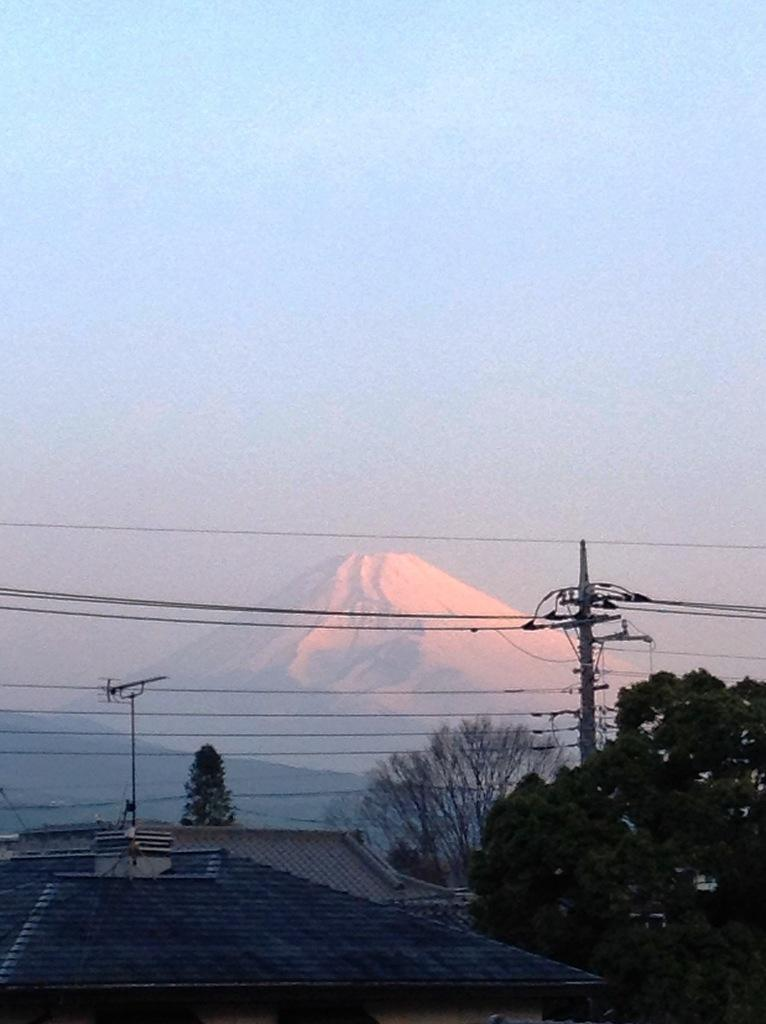What is located at the bottom of the image? There are buildings, trees, and electric poles at the bottom of the image. What type of natural feature can be seen at the bottom of the image? Mountains are visible on the ground in the image. What is the color of the sky in the background of the image? The sky in the background of the image is blue. What can be seen in the sky in the background of the image? There are clouds in the blue sky in the background of the image. What type of toy is being played with on the mountains in the image? There is no toy present in the image, and the mountains are not depicted as a location for play. Is the doll sitting on the electric poles in the image? There is no doll present in the image, so it cannot be sitting on the electric poles. 